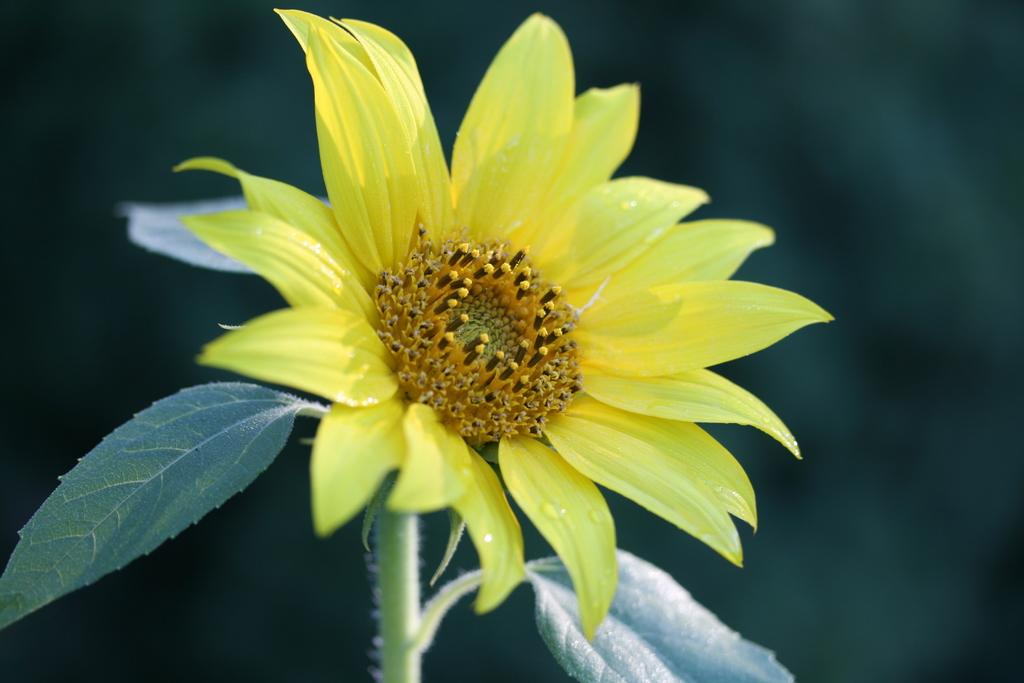What type of flower is in the image? There is a yellow flower in the image. What stage of growth is the flower in? The flower has buds. What else is present in the image besides the flower? There is a plant and leaves in the image. How would you describe the background of the image? The background of the image is blurred. What type of horn can be seen on the flower in the image? There is no horn present on the flower in the image; it is a yellow flower with buds. Can you tell me how many trays are stacked on the flower in the image? There are no trays present in the image; it features a yellow flower with buds and a plant with leaves. 